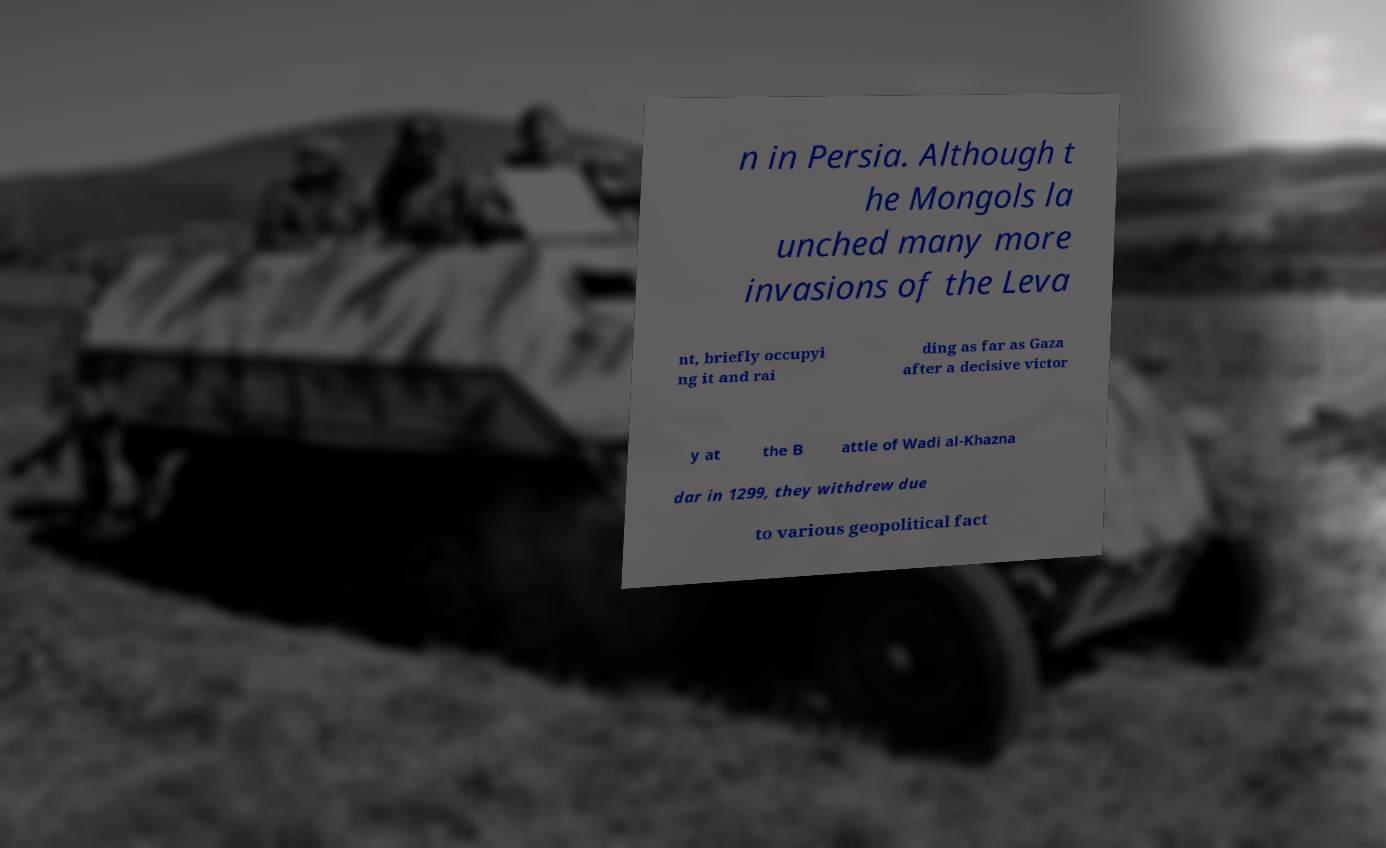There's text embedded in this image that I need extracted. Can you transcribe it verbatim? n in Persia. Although t he Mongols la unched many more invasions of the Leva nt, briefly occupyi ng it and rai ding as far as Gaza after a decisive victor y at the B attle of Wadi al-Khazna dar in 1299, they withdrew due to various geopolitical fact 